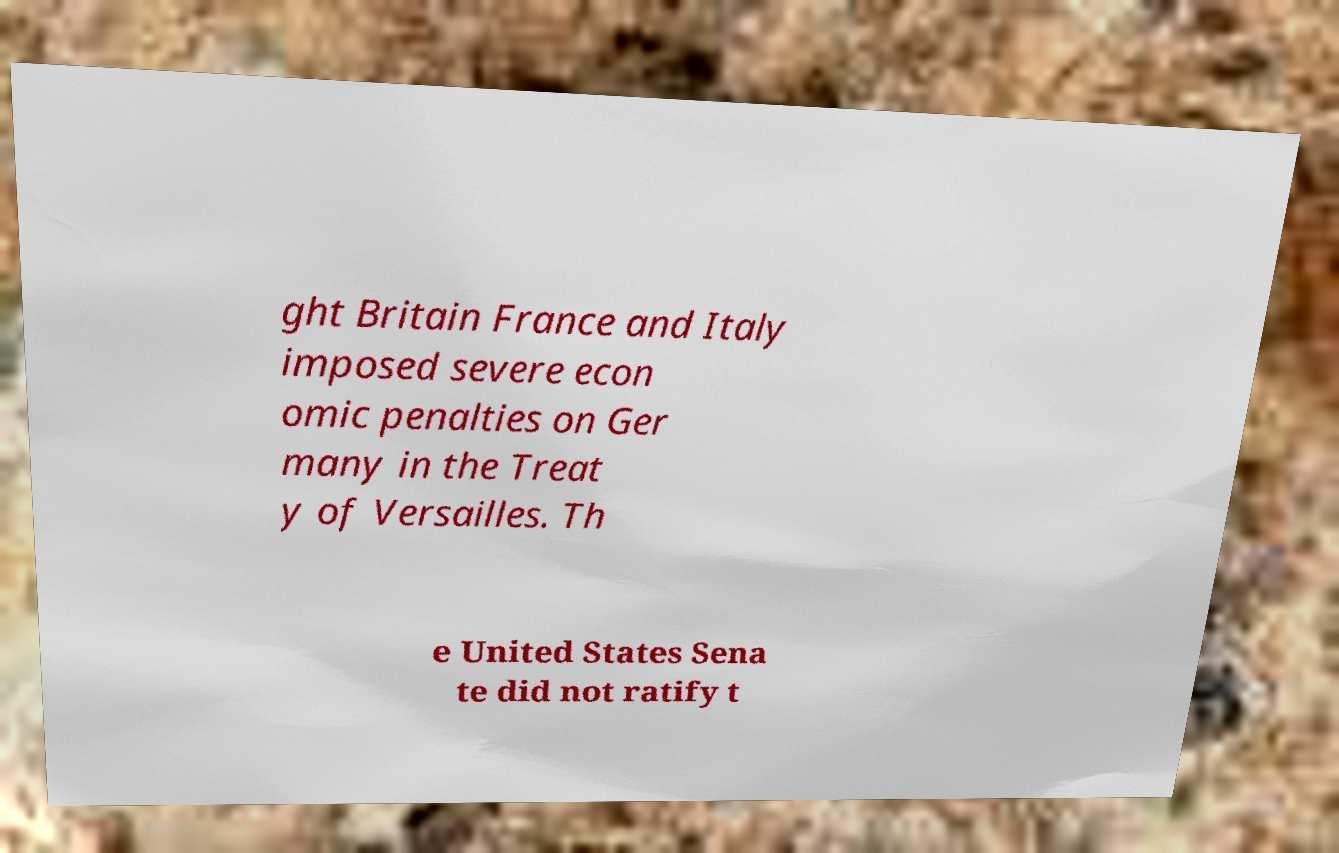What messages or text are displayed in this image? I need them in a readable, typed format. ght Britain France and Italy imposed severe econ omic penalties on Ger many in the Treat y of Versailles. Th e United States Sena te did not ratify t 